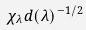Convert formula to latex. <formula><loc_0><loc_0><loc_500><loc_500>\chi _ { \lambda } d ( \lambda ) ^ { - 1 / 2 }</formula> 